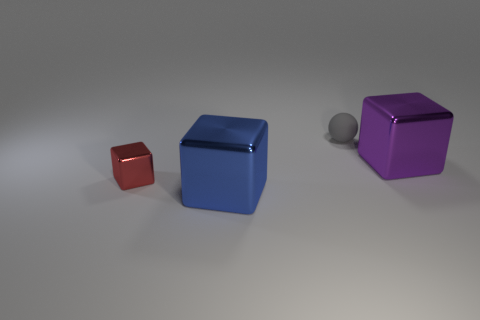Is there anything else that has the same material as the small ball?
Your answer should be very brief. No. What is the size of the matte object?
Keep it short and to the point. Small. There is a blue thing that is the same shape as the red metallic thing; what is its size?
Offer a very short reply. Large. There is a large metallic thing that is right of the small gray rubber ball; what number of big blue metal blocks are to the right of it?
Make the answer very short. 0. Do the thing that is on the right side of the gray rubber thing and the tiny thing that is left of the blue block have the same material?
Provide a succinct answer. Yes. How many other tiny gray things have the same shape as the small rubber thing?
Make the answer very short. 0. How many big blocks have the same color as the sphere?
Your response must be concise. 0. Do the large object in front of the big purple thing and the tiny object behind the small red shiny block have the same shape?
Offer a terse response. No. There is a cube that is behind the small thing that is in front of the big purple shiny thing; what number of tiny red metal things are behind it?
Provide a succinct answer. 0. The object that is on the right side of the small object that is to the right of the large shiny thing left of the purple metal cube is made of what material?
Give a very brief answer. Metal. 